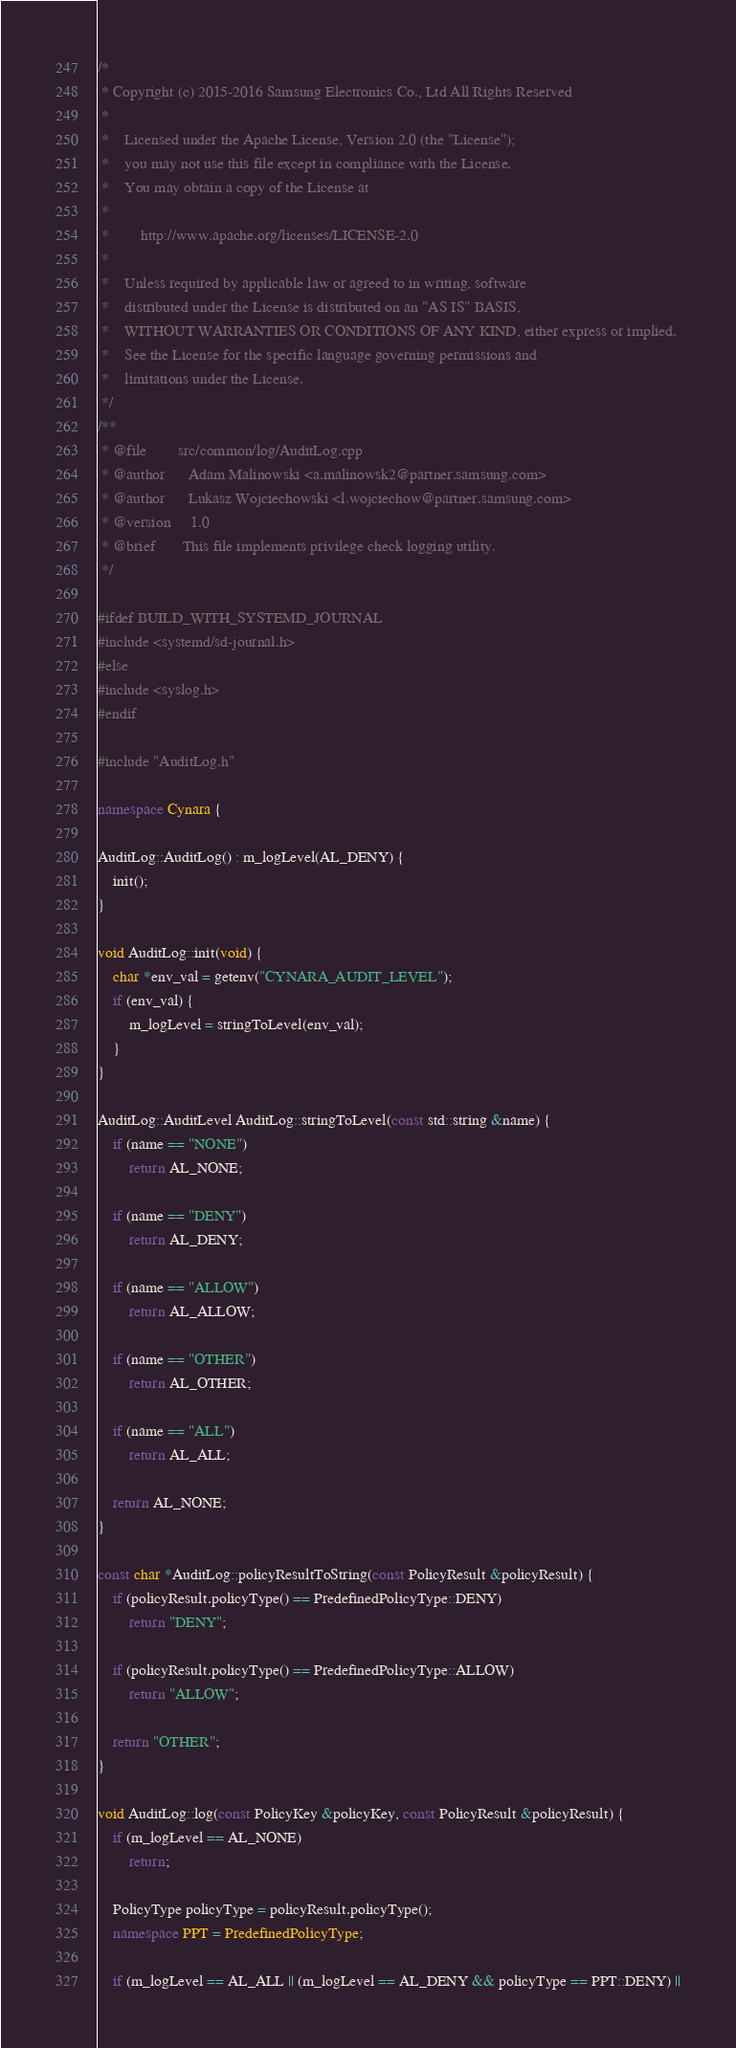Convert code to text. <code><loc_0><loc_0><loc_500><loc_500><_C++_>/*
 * Copyright (c) 2015-2016 Samsung Electronics Co., Ltd All Rights Reserved
 *
 *    Licensed under the Apache License, Version 2.0 (the "License");
 *    you may not use this file except in compliance with the License.
 *    You may obtain a copy of the License at
 *
 *        http://www.apache.org/licenses/LICENSE-2.0
 *
 *    Unless required by applicable law or agreed to in writing, software
 *    distributed under the License is distributed on an "AS IS" BASIS,
 *    WITHOUT WARRANTIES OR CONDITIONS OF ANY KIND, either express or implied.
 *    See the License for the specific language governing permissions and
 *    limitations under the License.
 */
/**
 * @file        src/common/log/AuditLog.cpp
 * @author      Adam Malinowski <a.malinowsk2@partner.samsung.com>
 * @author      Lukasz Wojciechowski <l.wojciechow@partner.samsung.com>
 * @version     1.0
 * @brief       This file implements privilege check logging utility.
 */

#ifdef BUILD_WITH_SYSTEMD_JOURNAL
#include <systemd/sd-journal.h>
#else
#include <syslog.h>
#endif

#include "AuditLog.h"

namespace Cynara {

AuditLog::AuditLog() : m_logLevel(AL_DENY) {
    init();
}

void AuditLog::init(void) {
    char *env_val = getenv("CYNARA_AUDIT_LEVEL");
    if (env_val) {
        m_logLevel = stringToLevel(env_val);
    }
}

AuditLog::AuditLevel AuditLog::stringToLevel(const std::string &name) {
    if (name == "NONE")
        return AL_NONE;

    if (name == "DENY")
        return AL_DENY;

    if (name == "ALLOW")
        return AL_ALLOW;

    if (name == "OTHER")
        return AL_OTHER;

    if (name == "ALL")
        return AL_ALL;

    return AL_NONE;
}

const char *AuditLog::policyResultToString(const PolicyResult &policyResult) {
    if (policyResult.policyType() == PredefinedPolicyType::DENY)
        return "DENY";

    if (policyResult.policyType() == PredefinedPolicyType::ALLOW)
        return "ALLOW";

    return "OTHER";
}

void AuditLog::log(const PolicyKey &policyKey, const PolicyResult &policyResult) {
    if (m_logLevel == AL_NONE)
        return;

    PolicyType policyType = policyResult.policyType();
    namespace PPT = PredefinedPolicyType;

    if (m_logLevel == AL_ALL || (m_logLevel == AL_DENY && policyType == PPT::DENY) ||</code> 